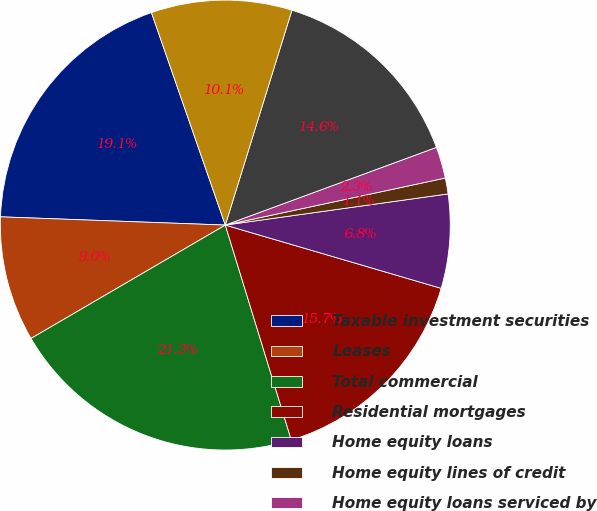<chart> <loc_0><loc_0><loc_500><loc_500><pie_chart><fcel>Taxable investment securities<fcel>Leases<fcel>Total commercial<fcel>Residential mortgages<fcel>Home equity loans<fcel>Home equity lines of credit<fcel>Home equity loans serviced by<fcel>Automobile<fcel>Education (1)<nl><fcel>19.09%<fcel>8.99%<fcel>21.33%<fcel>15.72%<fcel>6.75%<fcel>1.14%<fcel>2.26%<fcel>14.6%<fcel>10.11%<nl></chart> 